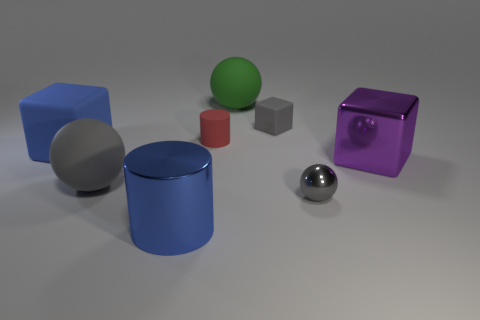Subtract all large blocks. How many blocks are left? 1 Subtract all balls. How many objects are left? 5 Subtract 1 spheres. How many spheres are left? 2 Subtract all blue blocks. Subtract all blue cylinders. How many blocks are left? 2 Subtract all blue cubes. How many purple balls are left? 0 Subtract all tiny rubber cylinders. Subtract all blue cylinders. How many objects are left? 6 Add 1 red matte cylinders. How many red matte cylinders are left? 2 Add 2 red rubber things. How many red rubber things exist? 3 Add 2 brown matte balls. How many objects exist? 10 Subtract all purple cubes. How many cubes are left? 2 